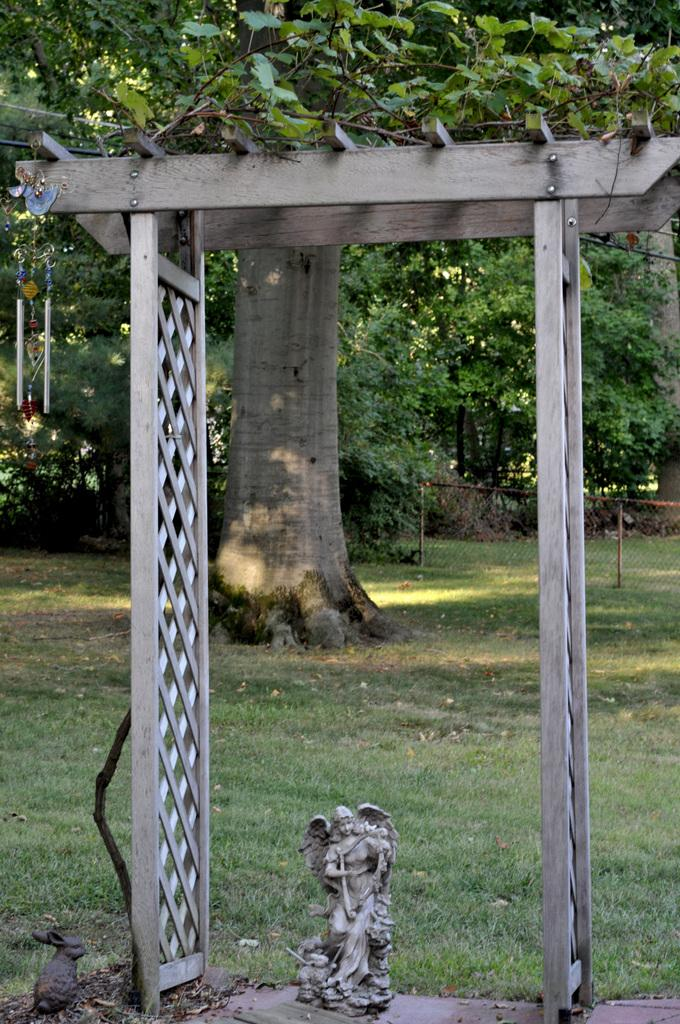What is the main subject of the image? There is a depiction of a woman in the image. Are there any animals present in the image? Yes, there is a rat in the image. What type of structure can be seen in the image? There is a wooden arch in the image. What type of vegetation is visible in the image? Trees and grass are visible in the image. What architectural feature is present in the image? There is a fence in the image. Where are the decor hangings located in the image? The decor hangings are present on the left side of the image. How many cows are grazing in the grass in the image? There are no cows present in the image; only a woman, a rat, a wooden arch, trees, grass, a fence, and decor hangings can be seen. 